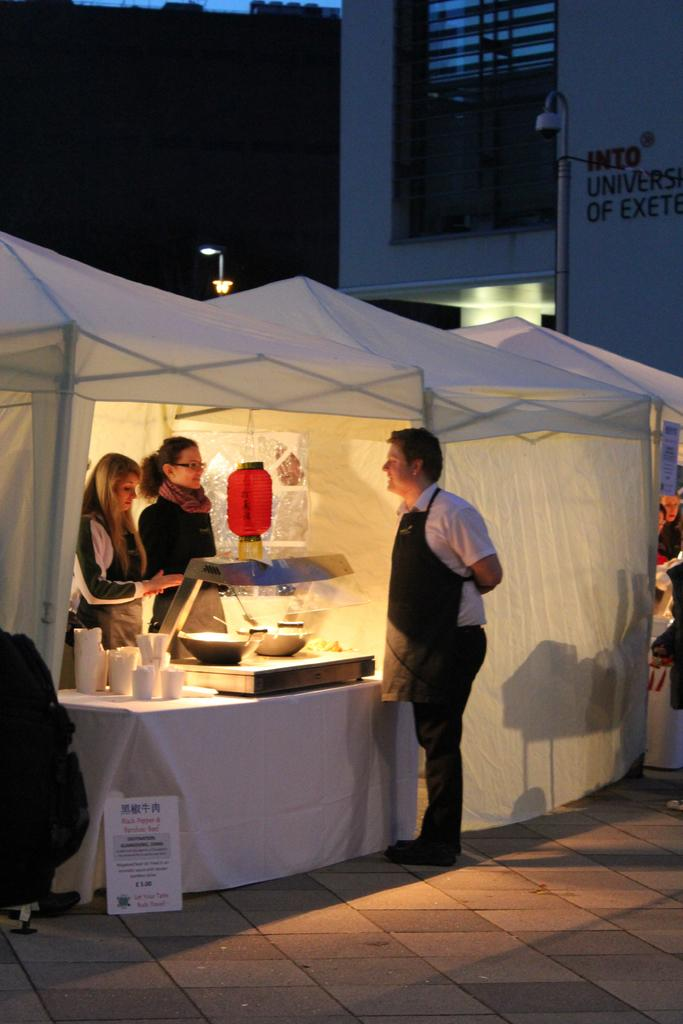What is the main subject of the image? The main subject of the image is a group of people. Can you describe the setting within the image? Two women are standing in a tent, and there is a machine in front of the tent. What can be seen in the background of the image? There are lights and a building visible in the background. What type of food is being prepared on the patch of grass in the image? There is no patch of grass or food preparation visible in the image. 